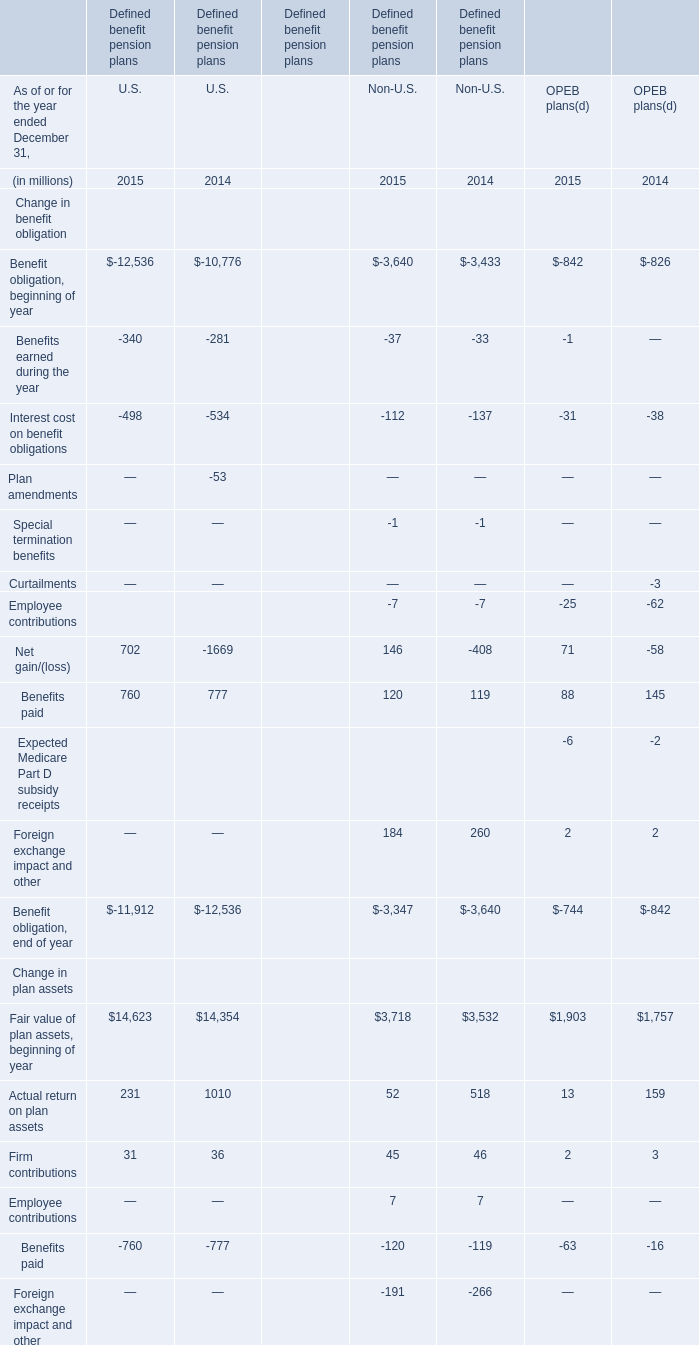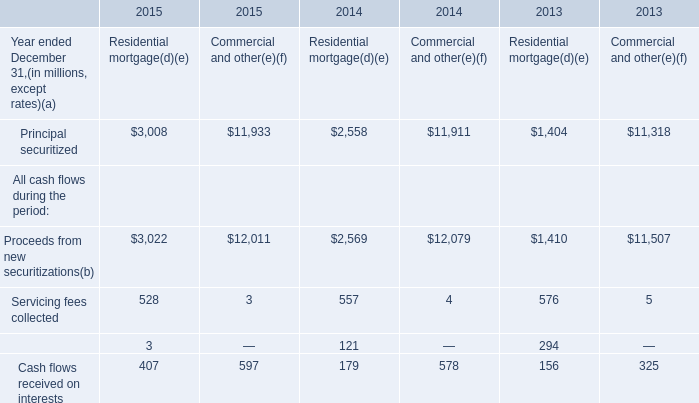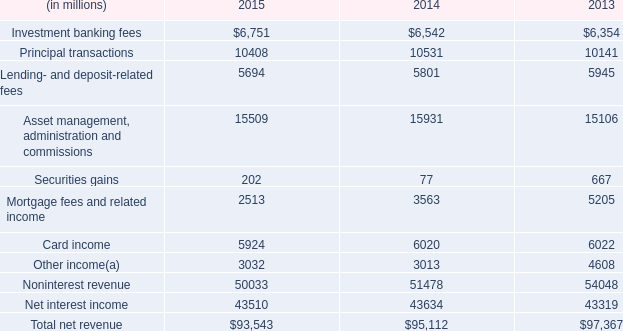What's the average of the Servicing fees collected for Residential mortgage(d)(e) in the years where Benefits paid for U.S. is positive? (in million) 
Computations: ((528 + 557) / 2)
Answer: 542.5. 